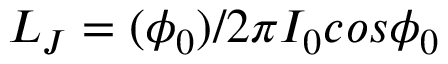<formula> <loc_0><loc_0><loc_500><loc_500>L _ { J } = ( \phi _ { 0 } ) / 2 \pi I _ { 0 } \cos \phi _ { 0 }</formula> 